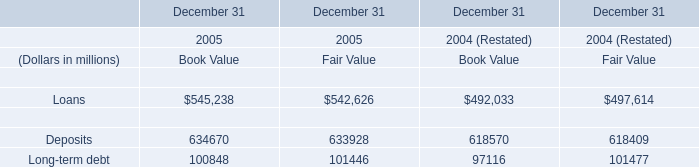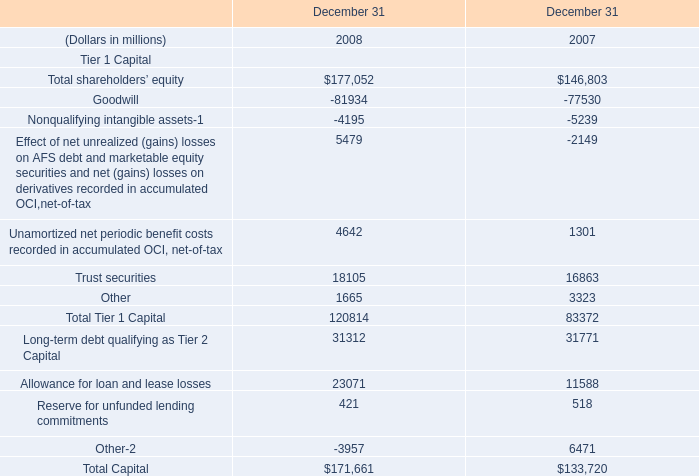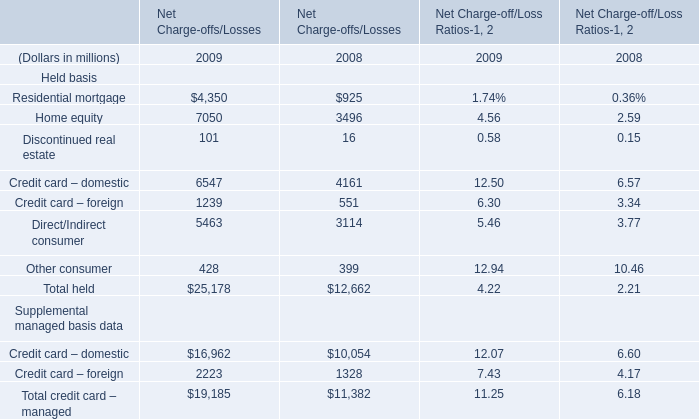what's the total amount of Deposits Financial liabilities of December 31 2005 Book Value, Trust securities of December 31 2008, and Goodwill of December 31 2008 ? 
Computations: ((634670.0 + 18105.0) + 81934.0)
Answer: 734709.0. 